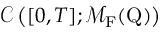Convert formula to latex. <formula><loc_0><loc_0><loc_500><loc_500>\mathcal { C } \left ( [ 0 , T ] ; \mathcal { M } _ { F } ( Q ) \right )</formula> 